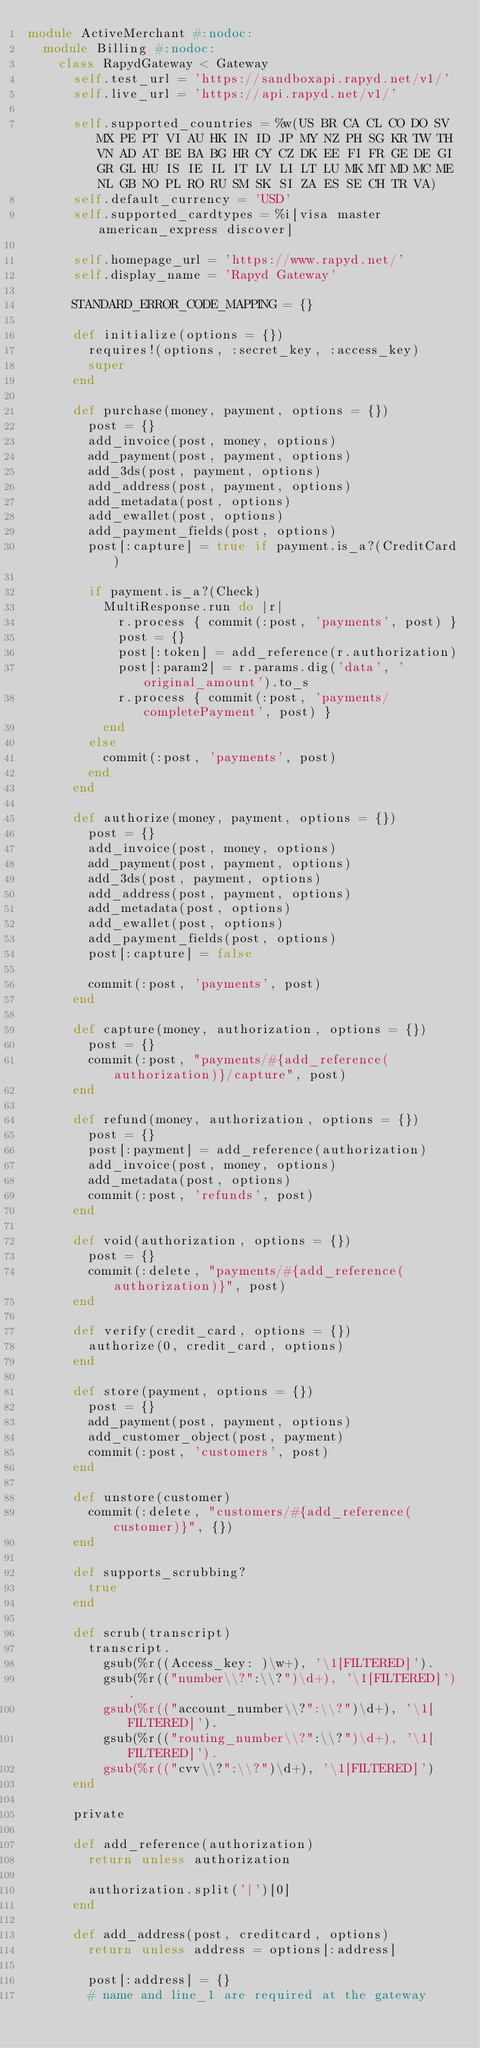<code> <loc_0><loc_0><loc_500><loc_500><_Ruby_>module ActiveMerchant #:nodoc:
  module Billing #:nodoc:
    class RapydGateway < Gateway
      self.test_url = 'https://sandboxapi.rapyd.net/v1/'
      self.live_url = 'https://api.rapyd.net/v1/'

      self.supported_countries = %w(US BR CA CL CO DO SV MX PE PT VI AU HK IN ID JP MY NZ PH SG KR TW TH VN AD AT BE BA BG HR CY CZ DK EE FI FR GE DE GI GR GL HU IS IE IL IT LV LI LT LU MK MT MD MC ME NL GB NO PL RO RU SM SK SI ZA ES SE CH TR VA)
      self.default_currency = 'USD'
      self.supported_cardtypes = %i[visa master american_express discover]

      self.homepage_url = 'https://www.rapyd.net/'
      self.display_name = 'Rapyd Gateway'

      STANDARD_ERROR_CODE_MAPPING = {}

      def initialize(options = {})
        requires!(options, :secret_key, :access_key)
        super
      end

      def purchase(money, payment, options = {})
        post = {}
        add_invoice(post, money, options)
        add_payment(post, payment, options)
        add_3ds(post, payment, options)
        add_address(post, payment, options)
        add_metadata(post, options)
        add_ewallet(post, options)
        add_payment_fields(post, options)
        post[:capture] = true if payment.is_a?(CreditCard)

        if payment.is_a?(Check)
          MultiResponse.run do |r|
            r.process { commit(:post, 'payments', post) }
            post = {}
            post[:token] = add_reference(r.authorization)
            post[:param2] = r.params.dig('data', 'original_amount').to_s
            r.process { commit(:post, 'payments/completePayment', post) }
          end
        else
          commit(:post, 'payments', post)
        end
      end

      def authorize(money, payment, options = {})
        post = {}
        add_invoice(post, money, options)
        add_payment(post, payment, options)
        add_3ds(post, payment, options)
        add_address(post, payment, options)
        add_metadata(post, options)
        add_ewallet(post, options)
        add_payment_fields(post, options)
        post[:capture] = false

        commit(:post, 'payments', post)
      end

      def capture(money, authorization, options = {})
        post = {}
        commit(:post, "payments/#{add_reference(authorization)}/capture", post)
      end

      def refund(money, authorization, options = {})
        post = {}
        post[:payment] = add_reference(authorization)
        add_invoice(post, money, options)
        add_metadata(post, options)
        commit(:post, 'refunds', post)
      end

      def void(authorization, options = {})
        post = {}
        commit(:delete, "payments/#{add_reference(authorization)}", post)
      end

      def verify(credit_card, options = {})
        authorize(0, credit_card, options)
      end

      def store(payment, options = {})
        post = {}
        add_payment(post, payment, options)
        add_customer_object(post, payment)
        commit(:post, 'customers', post)
      end

      def unstore(customer)
        commit(:delete, "customers/#{add_reference(customer)}", {})
      end

      def supports_scrubbing?
        true
      end

      def scrub(transcript)
        transcript.
          gsub(%r((Access_key: )\w+), '\1[FILTERED]').
          gsub(%r(("number\\?":\\?")\d+), '\1[FILTERED]').
          gsub(%r(("account_number\\?":\\?")\d+), '\1[FILTERED]').
          gsub(%r(("routing_number\\?":\\?")\d+), '\1[FILTERED]').
          gsub(%r(("cvv\\?":\\?")\d+), '\1[FILTERED]')
      end

      private

      def add_reference(authorization)
        return unless authorization

        authorization.split('|')[0]
      end

      def add_address(post, creditcard, options)
        return unless address = options[:address]

        post[:address] = {}
        # name and line_1 are required at the gateway</code> 